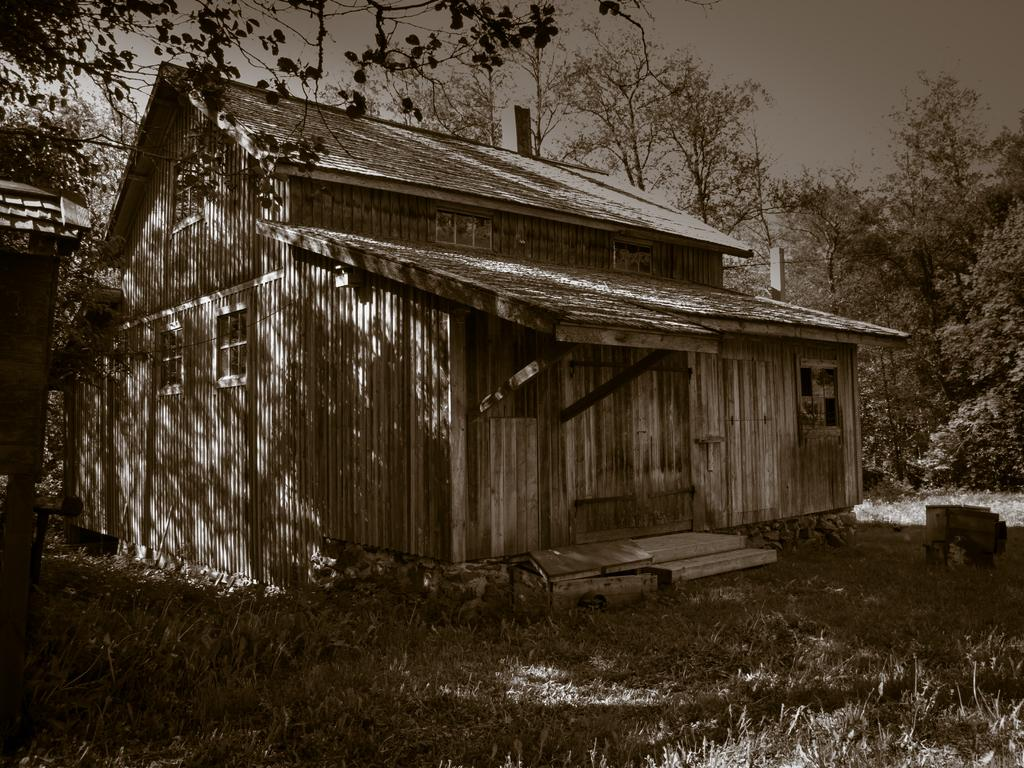What type of structure is present in the image? There is a house in the image. What type of vegetation can be seen in the image? There are trees in the image. What type of ground cover is visible in the image? There is grass visible in the image. What part of the natural environment is visible in the image? The sky is visible in the image. How many girls are riding the train in the image? There are no girls or trains present in the image. What type of event is taking place in the image? There is no event depicted in the image; it is a scene featuring a house, trees, grass, and the sky. 